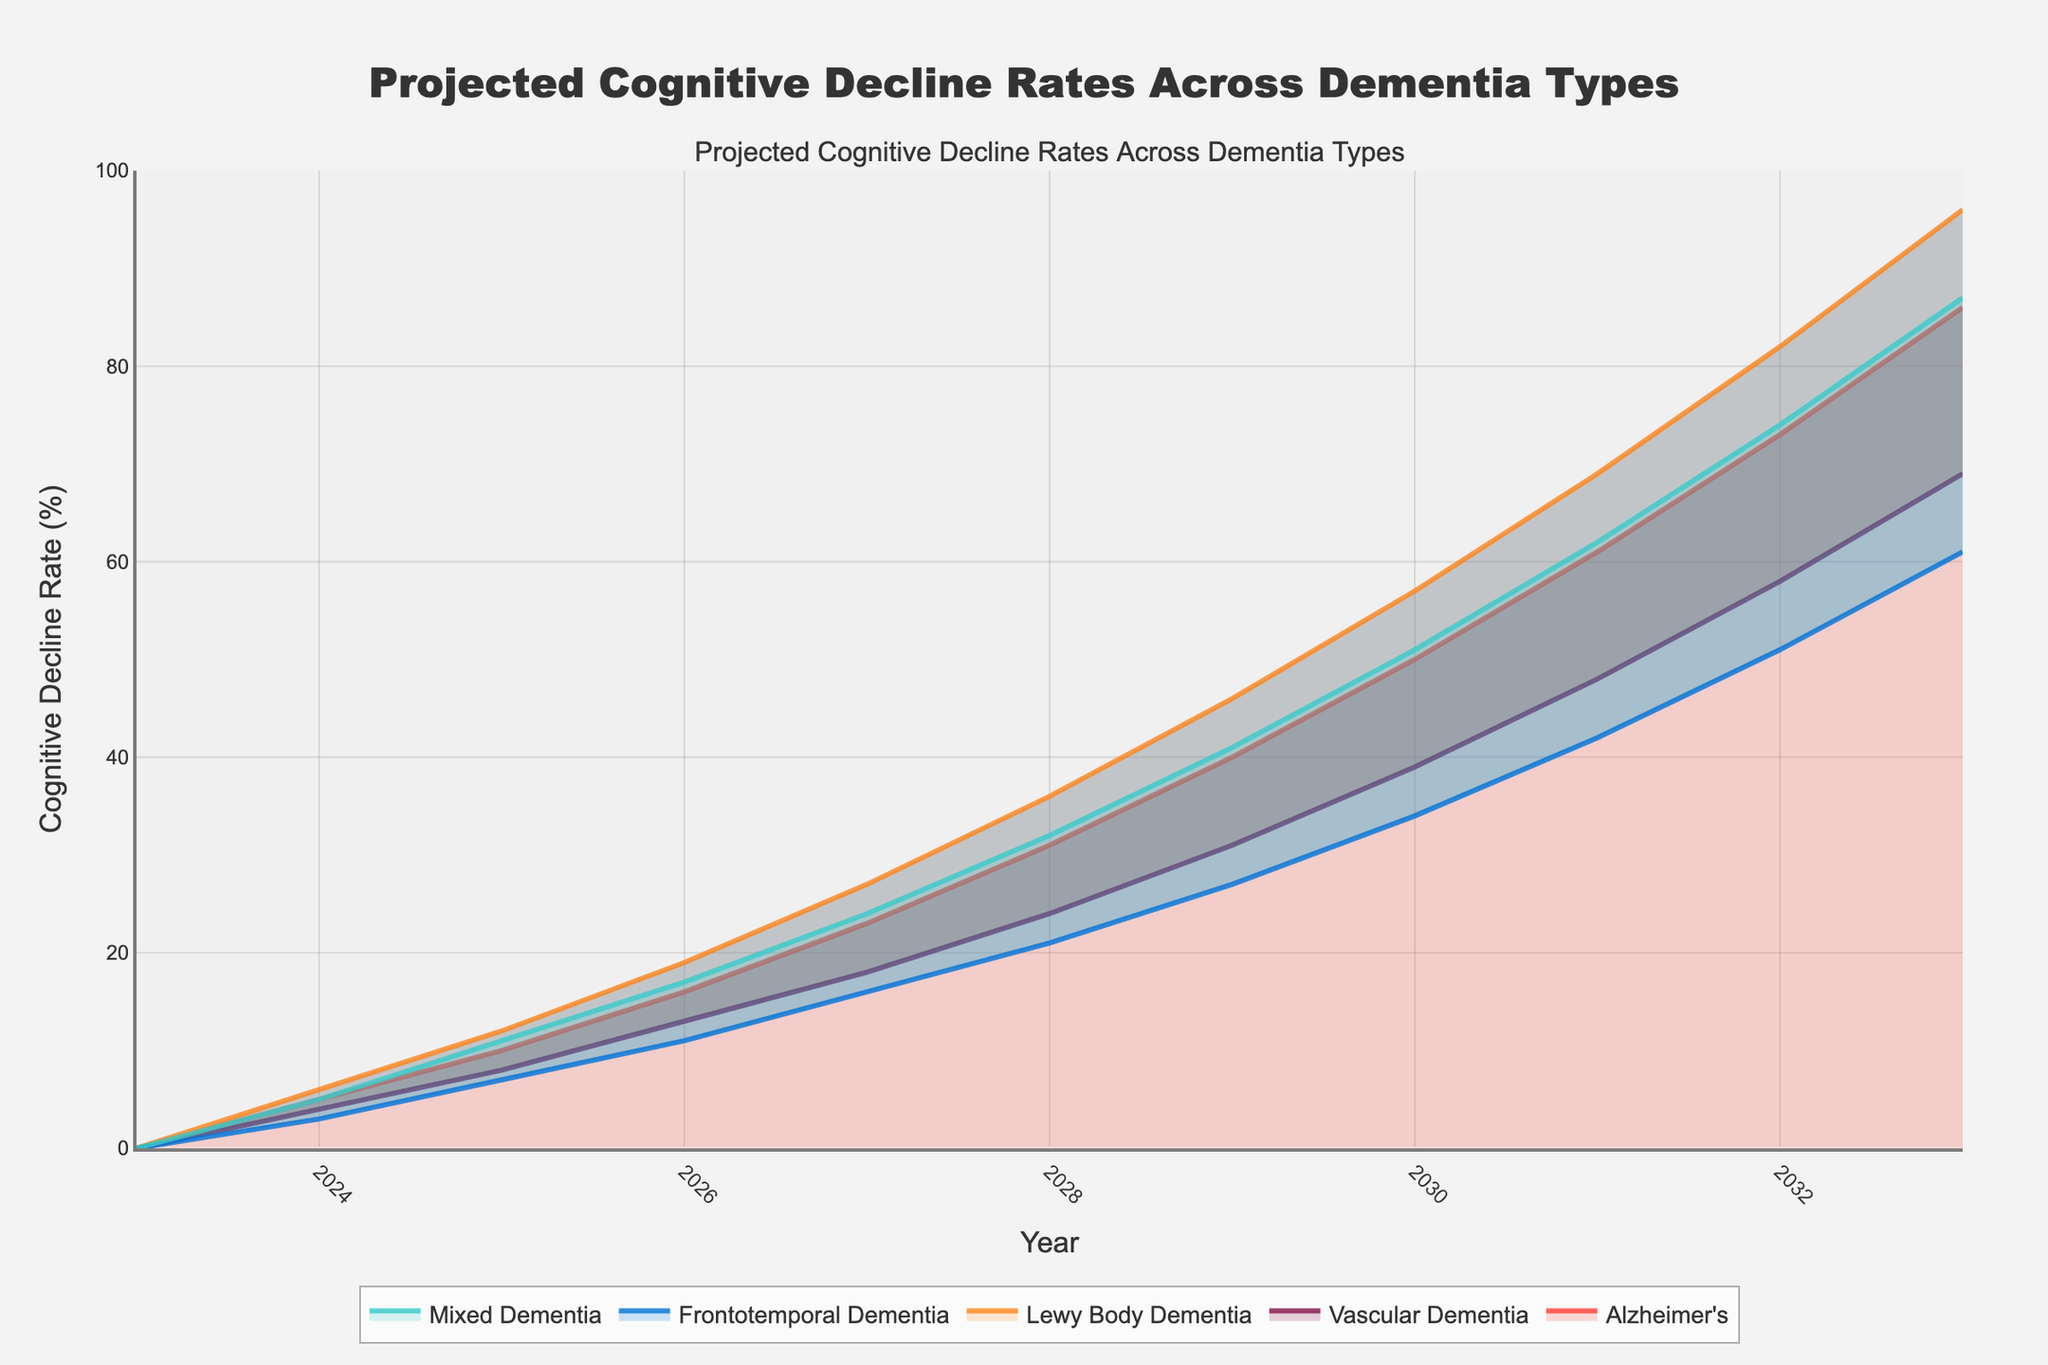What is the title of the figure? The title is displayed at the top of the figure and often summarizes the content or the main takeaway of the chart.
Answer: Projected Cognitive Decline Rates Across Dementia Types What type of dementia shows the highest projected cognitive decline rate in 2033? To find this, locate the year 2033 on the x-axis and compare the highest values of the y-axis for each type of dementia.
Answer: Alzheimer's Which type of dementia has the lowest projected cognitive decline rate in 2025? Locate the year 2025 on the x-axis and compare the values of the y-axis for each type of dementia. The lowest value will indicate the answer.
Answer: Frontotemporal Dementia How do the projected decline rates for Vascular Dementia and Mixed Dementia compare in 2027? Find the year 2027 on the x-axis and compare the y-values for Vascular Dementia and Mixed Dementia.
Answer: Vascular Dementia is lower What is the difference in projected decline rates between Lewy Body Dementia and Alzheimer's in 2029? Find the year 2029 on the x-axis and subtract the value for Alzheimer's from the value for Lewy Body Dementia.
Answer: 6% Which dementia type has the steepest increase in projected decline rates between 2024 and 2025? Calculate the difference between the 2024 and 2025 values for each dementia type and identify the highest difference.
Answer: Lewy Body Dementia By how much do the projected decline rates for Frontotemporal Dementia increase each year from 2026 to 2028? Calculate the yearly increase by subtracting the value of one year from the subsequent year for 2026, 2027, and 2028, then summarize the findings.
Answer: 4 (2026 to 2027), 5 (2027 to 2028) In which year do all dementia types have projected decline rates of 40% or more? Identify the year on the x-axis where all the y-values for the different dementia types are above or equal to 40%.
Answer: 2029 What is the color used for Lewy Body Dementia in the chart? Observe the color legend in the chart which correlates each dementia type with a specific color.
Answer: Orange How do the projected cognitive decline rates compare between Frontotemporal Dementia and Mixed Dementia in 2032? Analyze the projected values for these two types of dementia in the year 2032 on the y-axis and compare them.
Answer: Mixed Dementia is higher 